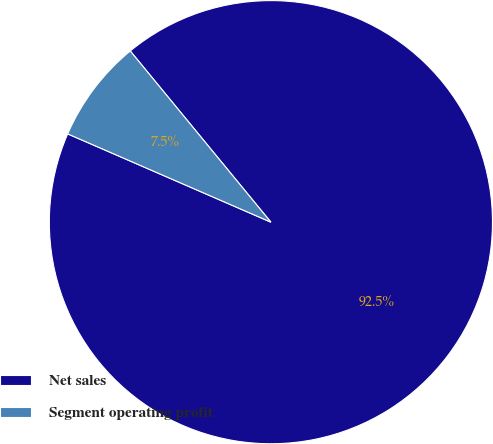Convert chart to OTSL. <chart><loc_0><loc_0><loc_500><loc_500><pie_chart><fcel>Net sales<fcel>Segment operating profit<nl><fcel>92.47%<fcel>7.53%<nl></chart> 